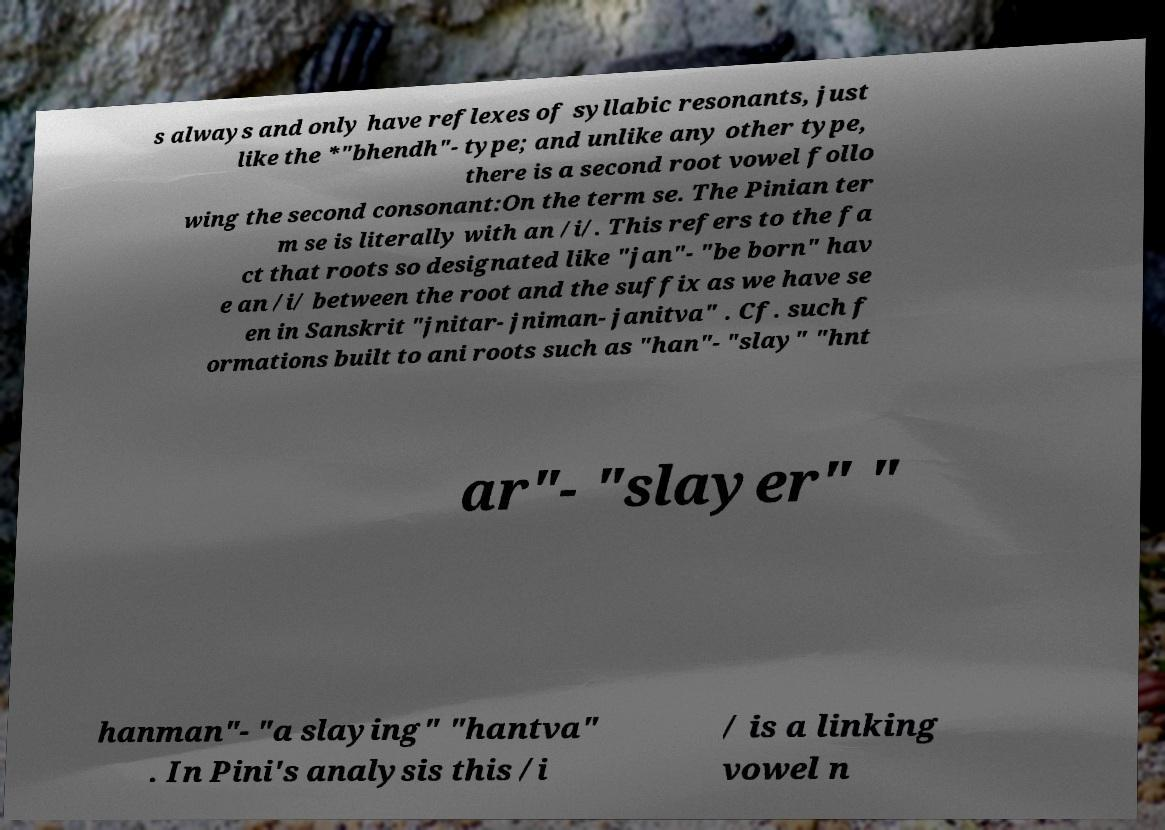Can you read and provide the text displayed in the image?This photo seems to have some interesting text. Can you extract and type it out for me? s always and only have reflexes of syllabic resonants, just like the *"bhendh"- type; and unlike any other type, there is a second root vowel follo wing the second consonant:On the term se. The Pinian ter m se is literally with an /i/. This refers to the fa ct that roots so designated like "jan"- "be born" hav e an /i/ between the root and the suffix as we have se en in Sanskrit "jnitar- jniman- janitva" . Cf. such f ormations built to ani roots such as "han"- "slay" "hnt ar"- "slayer" " hanman"- "a slaying" "hantva" . In Pini's analysis this /i / is a linking vowel n 